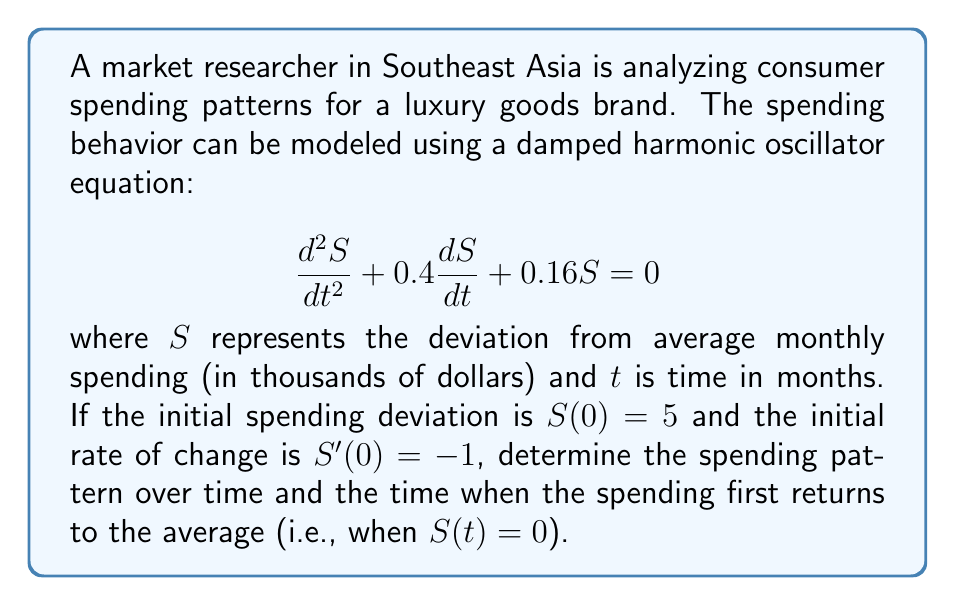Could you help me with this problem? To solve this problem, we need to follow these steps:

1) The general solution for a damped harmonic oscillator equation of the form $\frac{d^2S}{dt^2} + 2\beta\frac{dS}{dt} + \omega_0^2S = 0$ is:

   $S(t) = e^{-\beta t}(A\cos(\omega t) + B\sin(\omega t))$

   where $\omega = \sqrt{\omega_0^2 - \beta^2}$

2) In our case, $2\beta = 0.4$ and $\omega_0^2 = 0.16$. So:
   
   $\beta = 0.2$ and $\omega_0 = 0.4$

3) Calculate $\omega$:
   
   $\omega = \sqrt{0.4^2 - 0.2^2} = \sqrt{0.12} \approx 0.3464$

4) Our solution has the form:

   $S(t) = e^{-0.2t}(A\cos(0.3464t) + B\sin(0.3464t))$

5) Use initial conditions to find A and B:
   
   $S(0) = 5$, so $A = 5$
   
   $S'(t) = -0.2e^{-0.2t}(A\cos(0.3464t) + B\sin(0.3464t)) + e^{-0.2t}(-0.3464A\sin(0.3464t) + 0.3464B\cos(0.3464t))$
   
   $S'(0) = -1 = -0.2A + 0.3464B$
   
   $-1 = -0.2(5) + 0.3464B$
   
   $B \approx 1.4433$

6) The final solution is:

   $S(t) = e^{-0.2t}(5\cos(0.3464t) + 1.4433\sin(0.3464t))$

7) To find when $S(t) = 0$, we need to solve:

   $5\cos(0.3464t) + 1.4433\sin(0.3464t) = 0$

   $\tan(0.3464t) = -\frac{5}{1.4433} \approx -3.4642$

   $0.3464t = \arctan(-3.4642) + \pi \approx 2.5586$

   $t \approx 7.3862$ months
Answer: The spending pattern over time is given by:

$S(t) = e^{-0.2t}(5\cos(0.3464t) + 1.4433\sin(0.3464t))$

The spending first returns to the average (S(t) = 0) after approximately 7.39 months. 